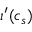Convert formula to latex. <formula><loc_0><loc_0><loc_500><loc_500>\iota ^ { \prime } ( c _ { s } )</formula> 